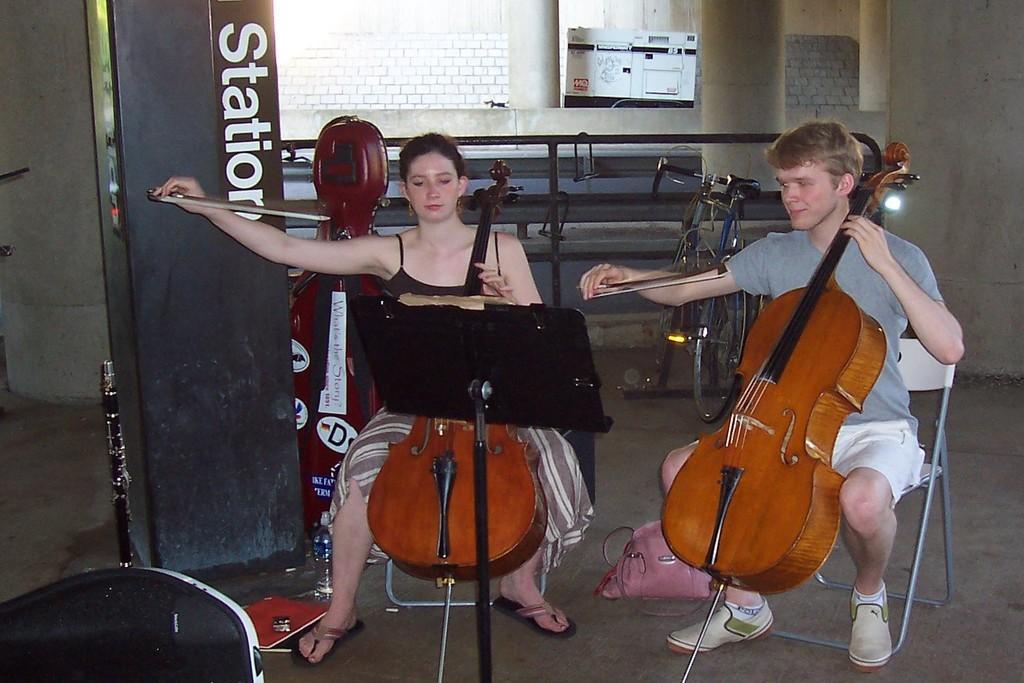In one or two sentences, can you explain what this image depicts? In this I can see a man and a woman are sitting on chairs. They are playing musical instruments. Here I can see bicycle, a pillar and a wall. On the left side I can see some other objects on the ground. 